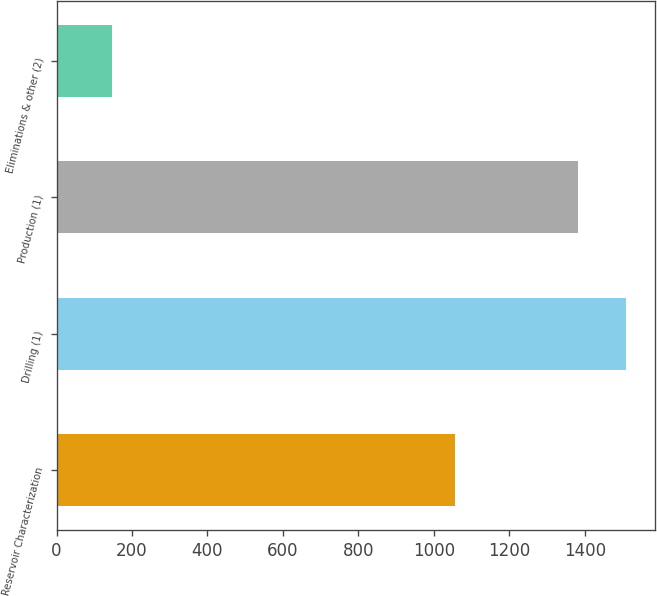<chart> <loc_0><loc_0><loc_500><loc_500><bar_chart><fcel>Reservoir Characterization<fcel>Drilling (1)<fcel>Production (1)<fcel>Eliminations & other (2)<nl><fcel>1057<fcel>1510.2<fcel>1383<fcel>148<nl></chart> 